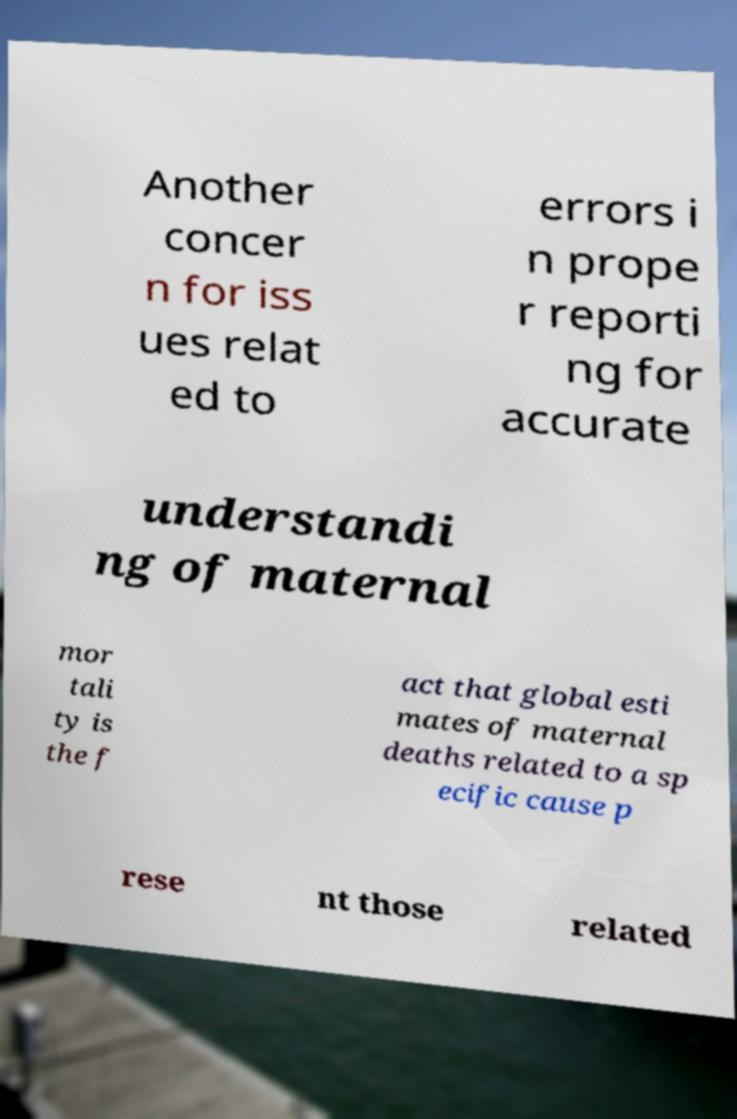Could you assist in decoding the text presented in this image and type it out clearly? Another concer n for iss ues relat ed to errors i n prope r reporti ng for accurate understandi ng of maternal mor tali ty is the f act that global esti mates of maternal deaths related to a sp ecific cause p rese nt those related 